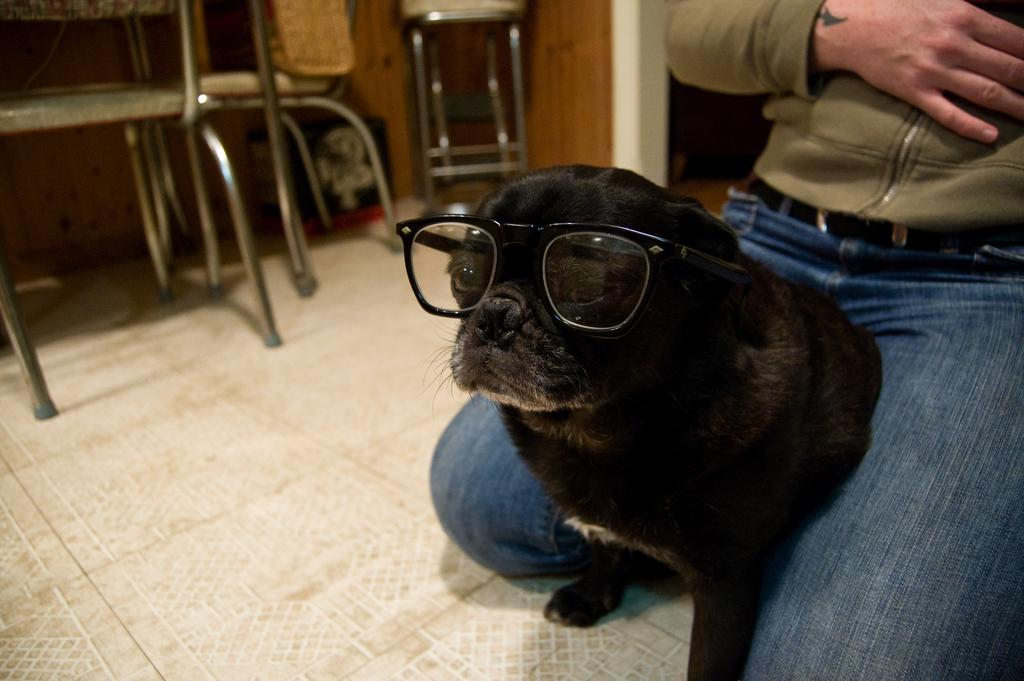What type of animal is in the image? There is a black cat in the image. What is unique about the appearance of the cat? The cat is wearing spectacles. What can be seen in the background of the image? There is a person, chairs, a wall, and a table in the background of the image. What other materials are visible in the background? There are other materials visible in the background of the image. Can you tell me how the cat is using the rake in the image? There is no rake present in the image; the cat is wearing spectacles and is not using any tools. Is the cat swimming in the image? No, the cat is not swimming in the image; it is sitting or standing on a surface. 